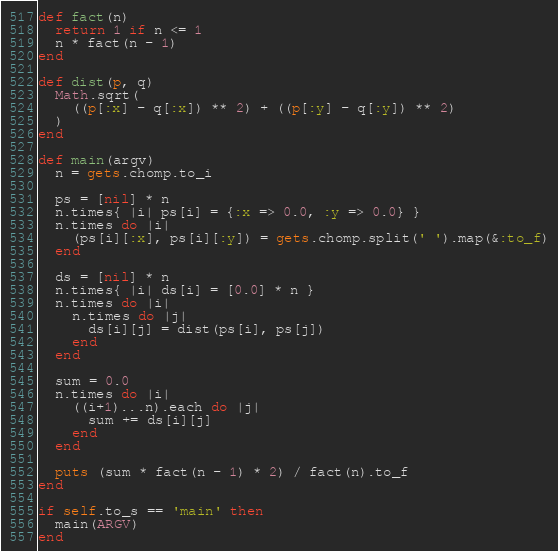<code> <loc_0><loc_0><loc_500><loc_500><_Ruby_>def fact(n)
  return 1 if n <= 1
  n * fact(n - 1)
end

def dist(p, q)
  Math.sqrt(
    ((p[:x] - q[:x]) ** 2) + ((p[:y] - q[:y]) ** 2)
  )
end

def main(argv)
  n = gets.chomp.to_i
  
  ps = [nil] * n
  n.times{ |i| ps[i] = {:x => 0.0, :y => 0.0} }
  n.times do |i|
    (ps[i][:x], ps[i][:y]) = gets.chomp.split(' ').map(&:to_f)
  end
  
  ds = [nil] * n
  n.times{ |i| ds[i] = [0.0] * n }
  n.times do |i|
    n.times do |j|
      ds[i][j] = dist(ps[i], ps[j])
    end
  end
  
  sum = 0.0
  n.times do |i|
    ((i+1)...n).each do |j|
      sum += ds[i][j]
    end
  end
  
  puts (sum * fact(n - 1) * 2) / fact(n).to_f
end

if self.to_s == 'main' then
  main(ARGV)
end</code> 